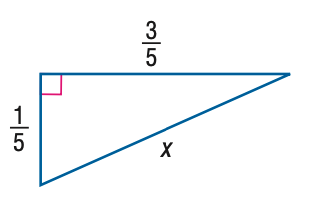Answer the mathemtical geometry problem and directly provide the correct option letter.
Question: Find x.
Choices: A: \frac { \sqrt { 5 } } { 10 } B: \frac { \sqrt { 10 } } { 10 } C: \frac { \sqrt { 5 } } { 5 } D: \frac { \sqrt { 10 } } { 5 } D 